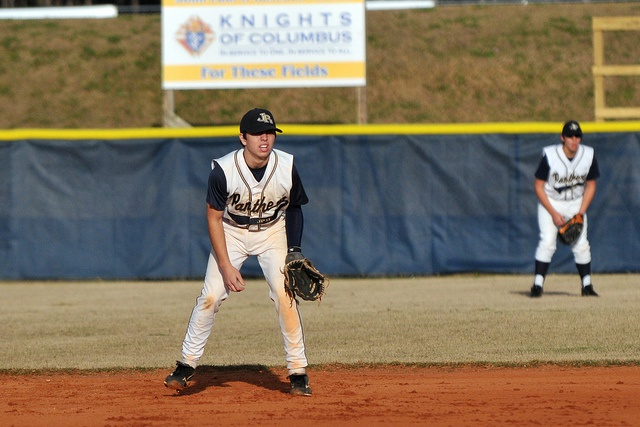Describe the objects in this image and their specific colors. I can see people in black, lightgray, gray, and darkgray tones, people in black, lightgray, darkgray, and gray tones, baseball glove in black, gray, and maroon tones, and baseball glove in black, brown, and maroon tones in this image. 